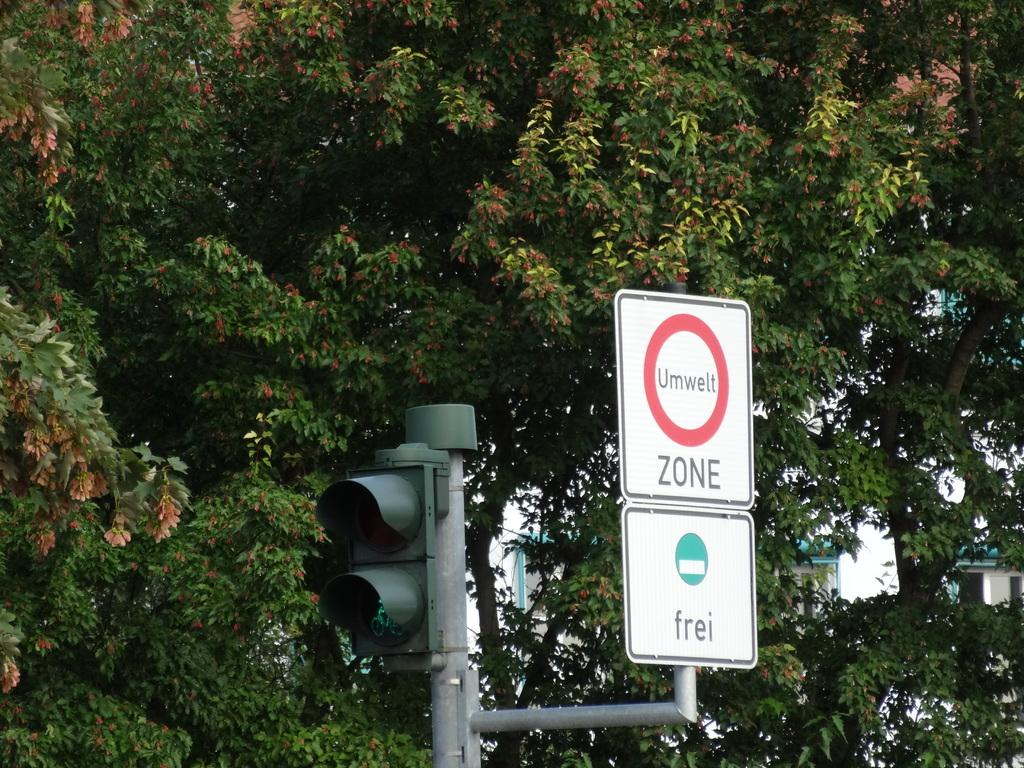Provide a one-sentence caption for the provided image. A sign for ZONE sits next to a stoplight. 